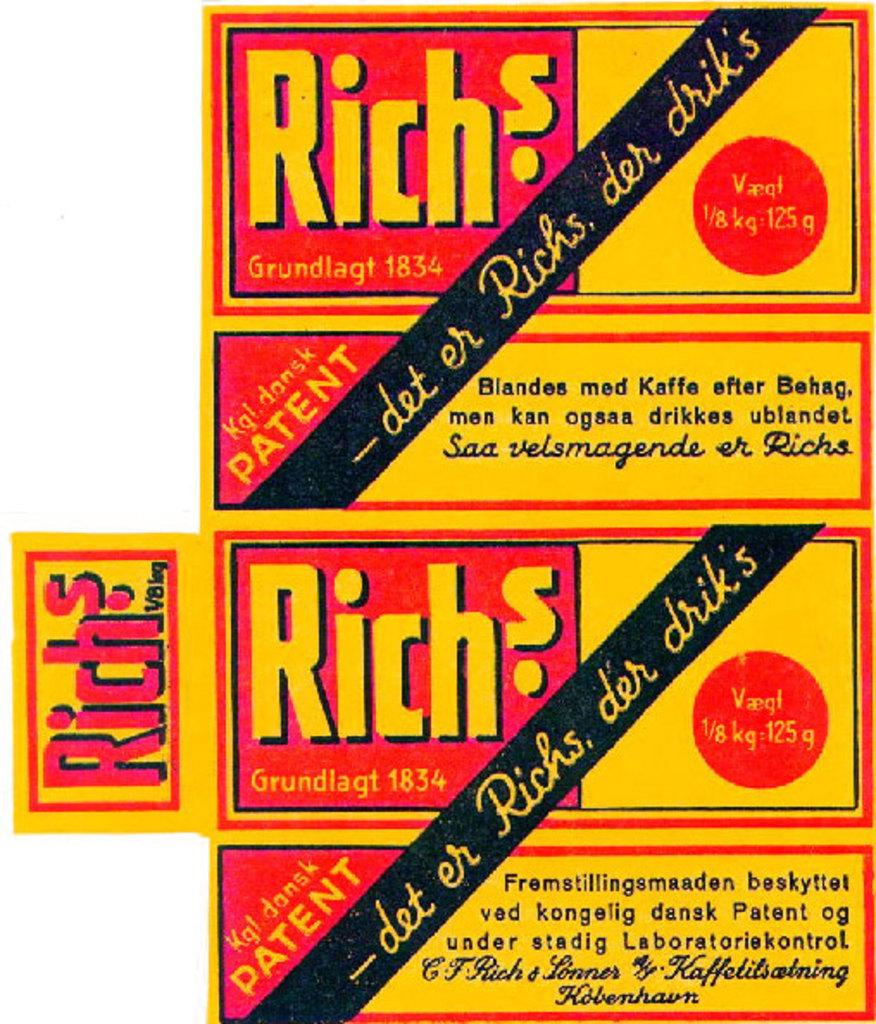<image>
Share a concise interpretation of the image provided. Orange and red Rich's label written in German. 